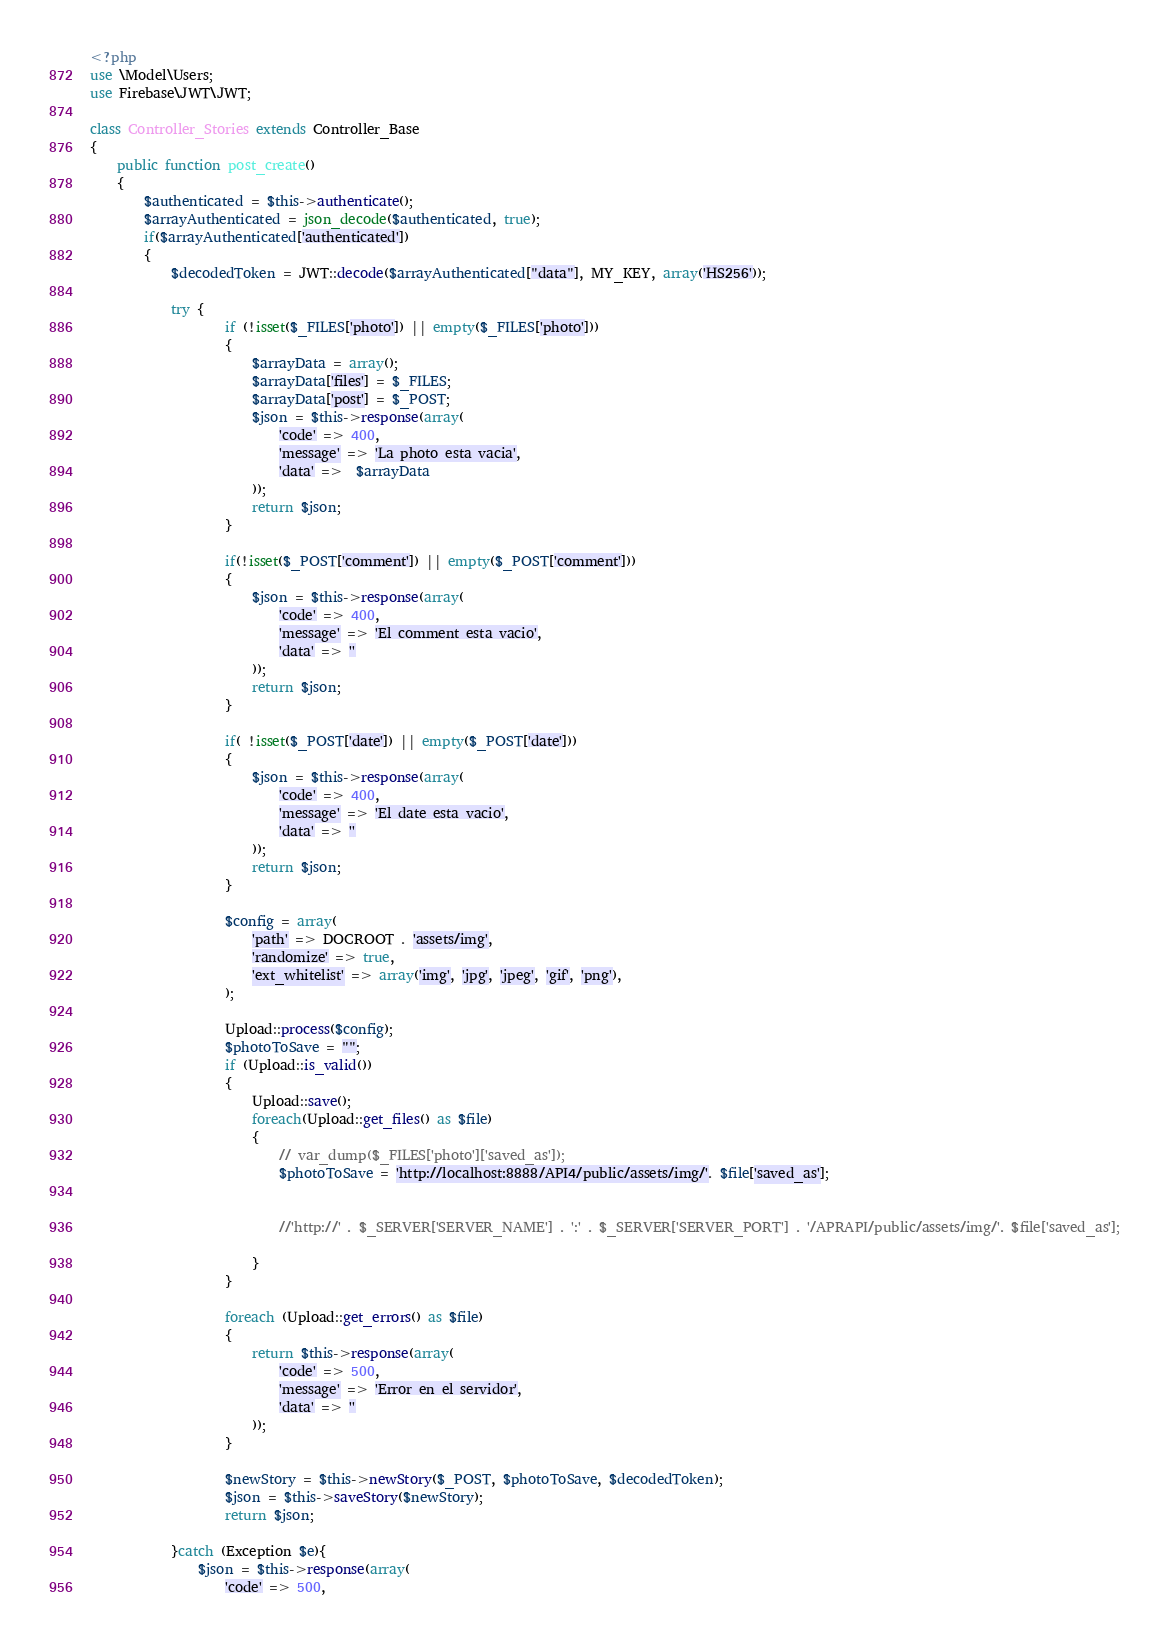Convert code to text. <code><loc_0><loc_0><loc_500><loc_500><_PHP_><?php
use \Model\Users;
use Firebase\JWT\JWT;

class Controller_Stories extends Controller_Base
{
  	public function post_create()
    {
    	$authenticated = $this->authenticate();
    	$arrayAuthenticated = json_decode($authenticated, true);
    	if($arrayAuthenticated['authenticated'])
    	{
    		$decodedToken = JWT::decode($arrayAuthenticated["data"], MY_KEY, array('HS256'));
    		
	        try {
		        	if (!isset($_FILES['photo']) || empty($_FILES['photo'])) 
		            {
		            	$arrayData = array();
		            	$arrayData['files'] = $_FILES;
		            	$arrayData['post'] = $_POST; 
		                $json = $this->response(array(
		                    'code' => 400,
		                    'message' => 'La photo esta vacia',
		                    'data' =>  $arrayData
		                ));
		                return $json;
		            }

		            if(!isset($_POST['comment']) || empty($_POST['comment']))
		            {
		            	$json = $this->response(array(
		                    'code' => 400,
		                    'message' => 'El comment esta vacio',
		                    'data' => '' 
		                ));
		                return $json;
		            }

		            if( !isset($_POST['date']) || empty($_POST['date']))
		            {
		            	$json = $this->response(array(
		                    'code' => 400,
		                    'message' => 'El date esta vacio',
		                    'data' => '' 
		                ));
		                return $json;
					}

	        	 	$config = array(
			            'path' => DOCROOT . 'assets/img',
			            'randomize' => true,
			            'ext_whitelist' => array('img', 'jpg', 'jpeg', 'gif', 'png'),
			        );

			        Upload::process($config);
			        $photoToSave = "";
			        if (Upload::is_valid())
			        {
			            Upload::save();
			            foreach(Upload::get_files() as $file)
			            {
			            	// var_dump($_FILES['photo']['saved_as']);
			            	$photoToSave = 'http://localhost:8888/API4/public/assets/img/'. $file['saved_as'];
			            	

			            	//'http://' . $_SERVER['SERVER_NAME'] . ':' . $_SERVER['SERVER_PORT'] . '/APRAPI/public/assets/img/'. $file['saved_as'];
			            	
			            }
			        }

			        foreach (Upload::get_errors() as $file)
			        {
			            return $this->response(array(
			                'code' => 500,
			                'message' => 'Error en el servidor',
			                'data' => '' 
			            ));
			        }
			    
		            $newStory = $this->newStory($_POST, $photoToSave, $decodedToken);
		           	$json = $this->saveStory($newStory);
		            return $json;
		        
	        }catch (Exception $e){
	            $json = $this->response(array(
	                'code' => 500,</code> 